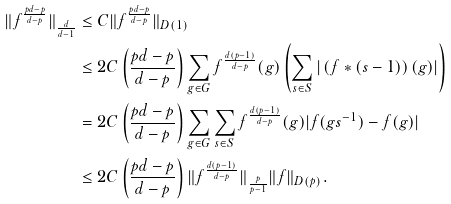<formula> <loc_0><loc_0><loc_500><loc_500>\| f ^ { \frac { p d - p } { d - p } } \| _ { \frac { d } { d - 1 } } & \leq C \| f ^ { \frac { p d - p } { d - p } } \| _ { D ( 1 ) } \\ & \leq 2 C \left ( \frac { p d - p } { d - p } \right ) \sum _ { g \in G } f ^ { \frac { d ( p - 1 ) } { d - p } } ( g ) \left ( \sum _ { s \in S } | \left ( f \ast ( s - 1 ) \right ) ( g ) | \right ) \\ & = 2 C \left ( \frac { p d - p } { d - p } \right ) \sum _ { g \in G } \sum _ { s \in S } f ^ { \frac { d ( p - 1 ) } { d - p } } ( g ) | f ( g s ^ { - 1 } ) - f ( g ) | \\ & \leq 2 C \left ( \frac { p d - p } { d - p } \right ) \| f ^ { \frac { d ( p - 1 ) } { d - p } } \| _ { \frac { p } { p - 1 } } \| f \| _ { D ( p ) } .</formula> 